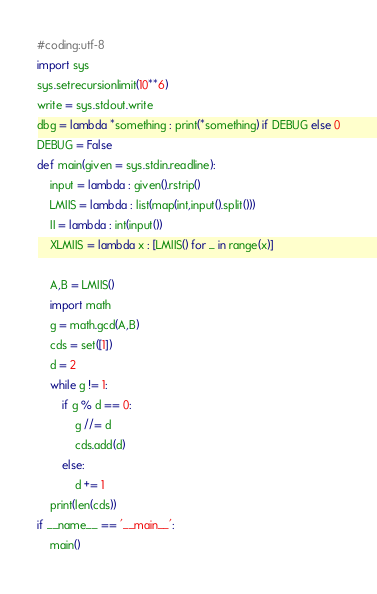<code> <loc_0><loc_0><loc_500><loc_500><_Python_>#coding:utf-8
import sys
sys.setrecursionlimit(10**6)
write = sys.stdout.write
dbg = lambda *something : print(*something) if DEBUG else 0
DEBUG = False
def main(given = sys.stdin.readline):
    input = lambda : given().rstrip()
    LMIIS = lambda : list(map(int,input().split()))
    II = lambda : int(input())
    XLMIIS = lambda x : [LMIIS() for _ in range(x)]

    A,B = LMIIS()
    import math
    g = math.gcd(A,B)
    cds = set([1])
    d = 2
    while g != 1:
        if g % d == 0:
            g //= d
            cds.add(d)
        else:
            d += 1
    print(len(cds))
if __name__ == '__main__':
    main()</code> 